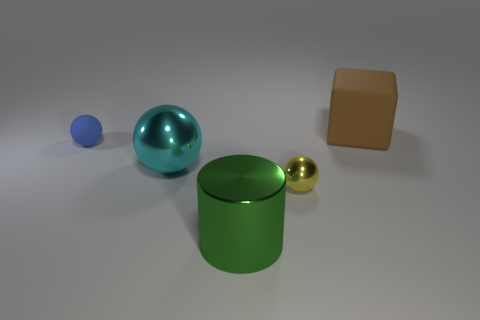Add 2 cyan metal balls. How many objects exist? 7 Subtract all balls. How many objects are left? 2 Subtract 0 purple spheres. How many objects are left? 5 Subtract all big blue rubber cylinders. Subtract all big green cylinders. How many objects are left? 4 Add 3 large things. How many large things are left? 6 Add 3 cyan shiny spheres. How many cyan shiny spheres exist? 4 